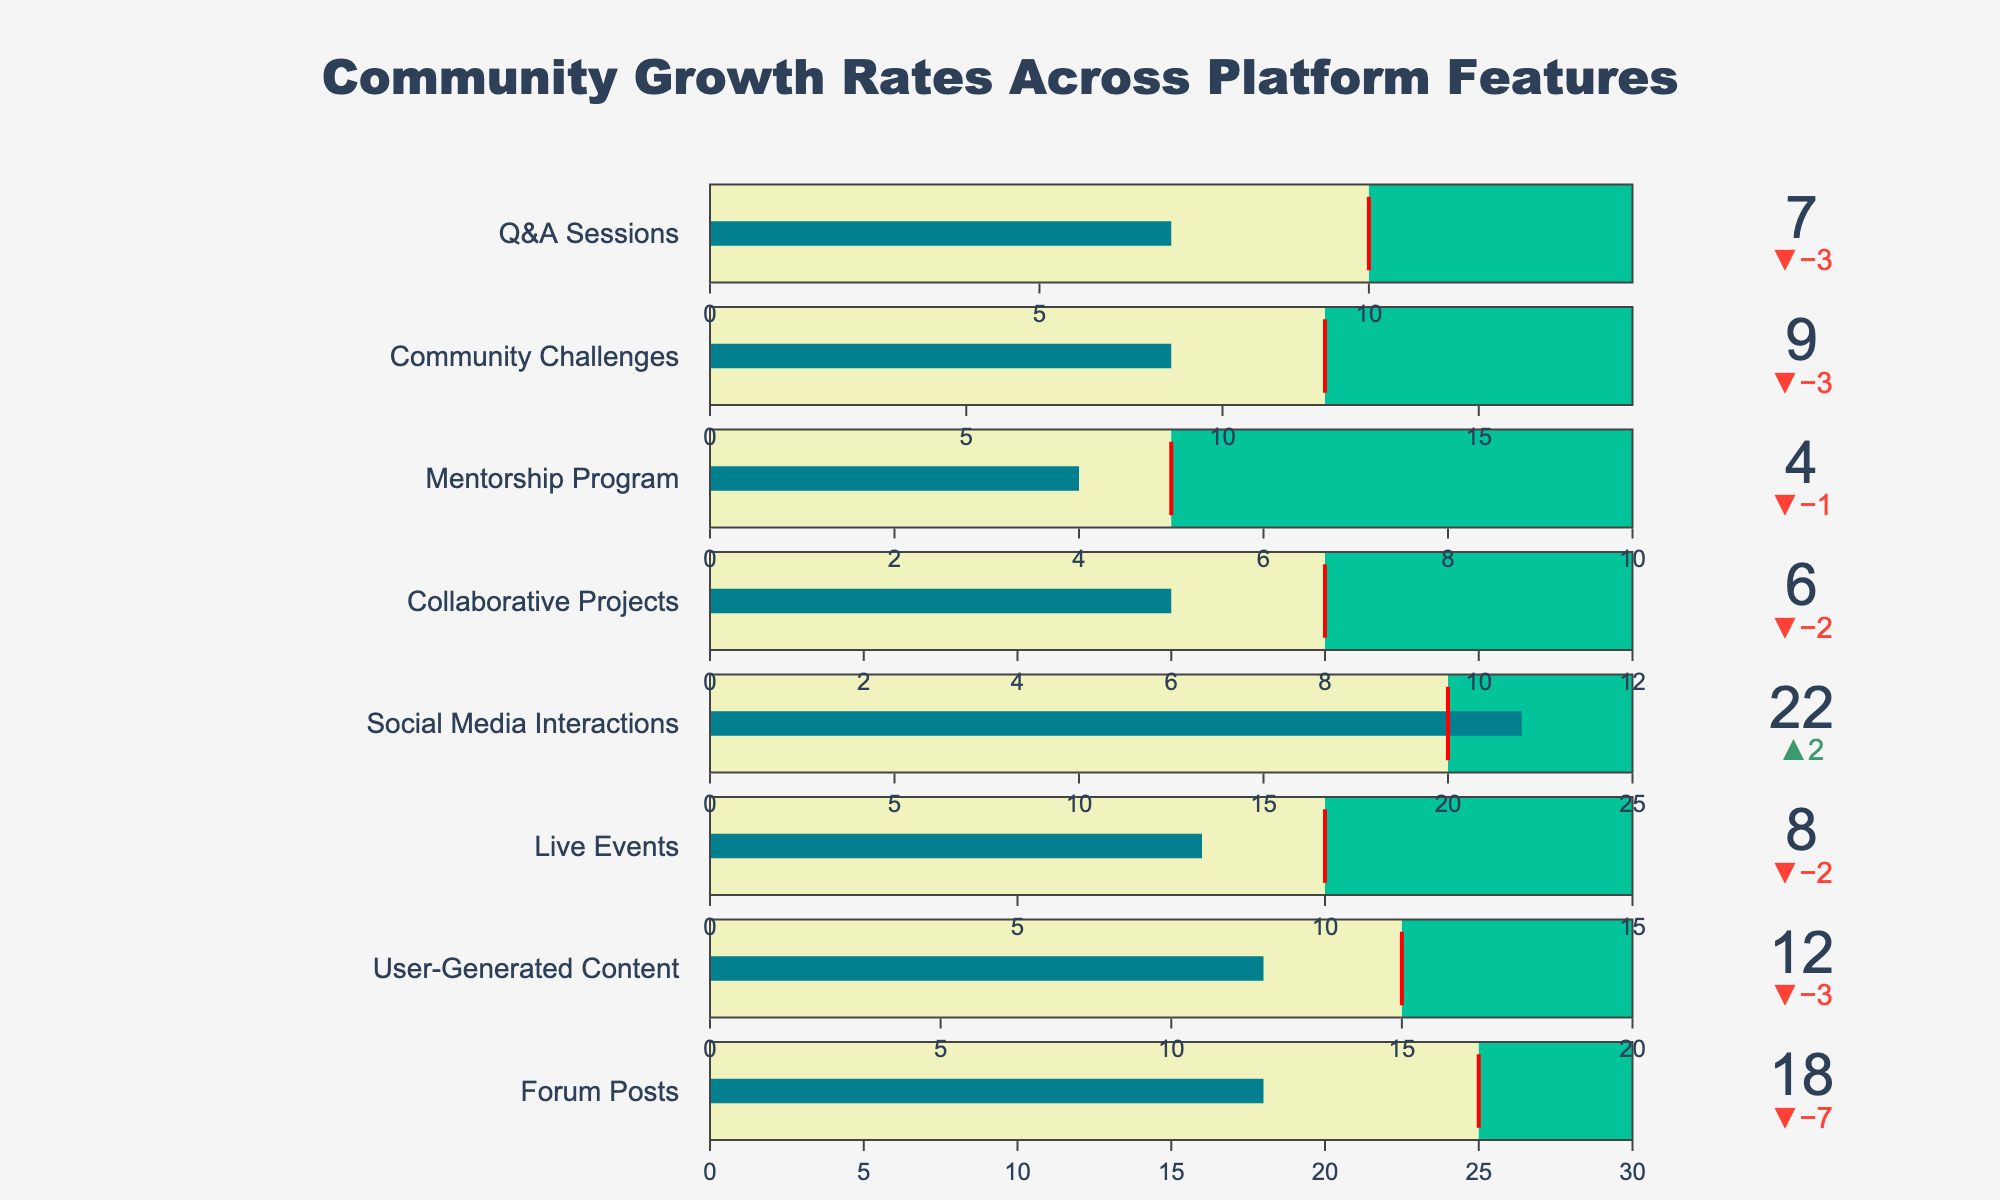How many features are displayed in the figure? The figure shows multiple growth rates across platform features; count the unique entries to determine the number of features. There are 8 features listed in the data table.
Answer: 8 What is the maximum growth rate for "Live Events"? Look for "Live Events" in the figure, identify the rightmost value plotted for this feature. The maximum growth rate for "Live Events" is 15.
Answer: 15 Which feature exceeded its target growth? To find out which feature exceeded its target, compare the actual growth with the target growth for each feature. For "Social Media Interactions," the actual growth (22) is greater than the target growth (20).
Answer: Social Media Interactions What is the difference between the actual and target growth for "Forum Posts"? Subtract the target growth from the actual growth for "Forum Posts." The actual growth is 18 and the target growth is 25, so the difference is 18 - 25 = -7.
Answer: -7 Which feature has the lowest actual growth rate, and what is the value? Find the feature with the smallest actual growth rate by comparing the values across all features. The "Mentorship Program" has the lowest actual growth rate at 4.
Answer: Mentorship Program, 4 What is the sum of the actual growth rates for "Community Challenges" and "Q&A Sessions"? Add the actual growth rates for "Community Challenges" and "Q&A Sessions." The value for "Community Challenges" is 9 and for "Q&A Sessions" is 7, so the sum is 9 + 7 = 16.
Answer: 16 Which feature has the largest gap between its maximum growth and its actual growth rate? Calculate the gap for each feature by subtracting the actual growth from the maximum growth and identify the largest one. For "Mentorship Program," the gap is 10 - 4 = 6, for the others, the gaps are smaller.
Answer: Mentorship Program Is the actual growth rate for "Collaborative Projects" more than half of its maximum growth rate? Compare the actual growth rate to half of the maximum growth rate. For "Collaborative Projects," the actual growth rate is 6 and half of the maximum growth rate of 12 is 6. Since 6 = 6, it is equal to half.
Answer: Yes What's the average target growth rate across all features? Add the target growth rates and divide by the number of features. The sum of target growth rates (25+15+10+20+8+5+12+10) is 105. The number of features is 8, therefore the average is 105/8 = 13.125.
Answer: 13.125 